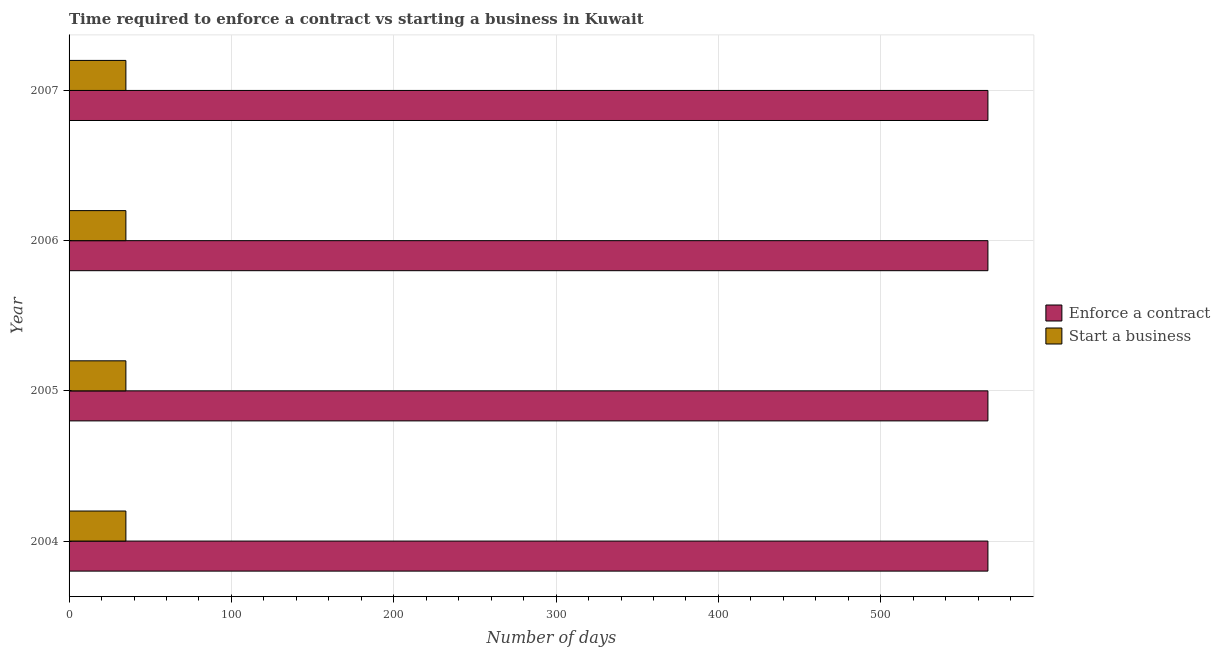How many different coloured bars are there?
Offer a very short reply. 2. How many groups of bars are there?
Provide a succinct answer. 4. Are the number of bars per tick equal to the number of legend labels?
Ensure brevity in your answer.  Yes. Are the number of bars on each tick of the Y-axis equal?
Make the answer very short. Yes. What is the label of the 1st group of bars from the top?
Make the answer very short. 2007. What is the number of days to start a business in 2007?
Offer a very short reply. 35. Across all years, what is the maximum number of days to enforece a contract?
Your answer should be compact. 566. Across all years, what is the minimum number of days to start a business?
Give a very brief answer. 35. In which year was the number of days to enforece a contract maximum?
Ensure brevity in your answer.  2004. What is the total number of days to enforece a contract in the graph?
Offer a very short reply. 2264. What is the difference between the number of days to start a business in 2005 and that in 2006?
Keep it short and to the point. 0. What is the difference between the number of days to enforece a contract in 2006 and the number of days to start a business in 2004?
Make the answer very short. 531. What is the average number of days to start a business per year?
Your answer should be very brief. 35. In the year 2006, what is the difference between the number of days to start a business and number of days to enforece a contract?
Give a very brief answer. -531. In how many years, is the number of days to start a business greater than 100 days?
Provide a succinct answer. 0. What is the ratio of the number of days to start a business in 2004 to that in 2005?
Your response must be concise. 1. Is the number of days to start a business in 2004 less than that in 2005?
Offer a terse response. No. Is the difference between the number of days to start a business in 2006 and 2007 greater than the difference between the number of days to enforece a contract in 2006 and 2007?
Provide a short and direct response. No. In how many years, is the number of days to enforece a contract greater than the average number of days to enforece a contract taken over all years?
Give a very brief answer. 0. Is the sum of the number of days to enforece a contract in 2005 and 2007 greater than the maximum number of days to start a business across all years?
Provide a succinct answer. Yes. What does the 1st bar from the top in 2005 represents?
Make the answer very short. Start a business. What does the 1st bar from the bottom in 2006 represents?
Offer a very short reply. Enforce a contract. How many bars are there?
Make the answer very short. 8. Are the values on the major ticks of X-axis written in scientific E-notation?
Your answer should be compact. No. Does the graph contain any zero values?
Keep it short and to the point. No. How many legend labels are there?
Your response must be concise. 2. What is the title of the graph?
Make the answer very short. Time required to enforce a contract vs starting a business in Kuwait. Does "RDB concessional" appear as one of the legend labels in the graph?
Your answer should be very brief. No. What is the label or title of the X-axis?
Provide a short and direct response. Number of days. What is the label or title of the Y-axis?
Keep it short and to the point. Year. What is the Number of days in Enforce a contract in 2004?
Make the answer very short. 566. What is the Number of days of Start a business in 2004?
Offer a terse response. 35. What is the Number of days of Enforce a contract in 2005?
Provide a succinct answer. 566. What is the Number of days in Start a business in 2005?
Ensure brevity in your answer.  35. What is the Number of days in Enforce a contract in 2006?
Offer a terse response. 566. What is the Number of days of Start a business in 2006?
Provide a succinct answer. 35. What is the Number of days in Enforce a contract in 2007?
Your answer should be compact. 566. Across all years, what is the maximum Number of days of Enforce a contract?
Make the answer very short. 566. Across all years, what is the maximum Number of days in Start a business?
Offer a terse response. 35. Across all years, what is the minimum Number of days of Enforce a contract?
Your response must be concise. 566. Across all years, what is the minimum Number of days of Start a business?
Keep it short and to the point. 35. What is the total Number of days in Enforce a contract in the graph?
Offer a very short reply. 2264. What is the total Number of days of Start a business in the graph?
Provide a succinct answer. 140. What is the difference between the Number of days of Start a business in 2004 and that in 2005?
Your answer should be compact. 0. What is the difference between the Number of days in Start a business in 2004 and that in 2006?
Your answer should be compact. 0. What is the difference between the Number of days of Start a business in 2004 and that in 2007?
Provide a short and direct response. 0. What is the difference between the Number of days in Enforce a contract in 2005 and that in 2006?
Ensure brevity in your answer.  0. What is the difference between the Number of days of Enforce a contract in 2004 and the Number of days of Start a business in 2005?
Ensure brevity in your answer.  531. What is the difference between the Number of days in Enforce a contract in 2004 and the Number of days in Start a business in 2006?
Offer a very short reply. 531. What is the difference between the Number of days of Enforce a contract in 2004 and the Number of days of Start a business in 2007?
Your answer should be very brief. 531. What is the difference between the Number of days of Enforce a contract in 2005 and the Number of days of Start a business in 2006?
Provide a succinct answer. 531. What is the difference between the Number of days of Enforce a contract in 2005 and the Number of days of Start a business in 2007?
Your response must be concise. 531. What is the difference between the Number of days of Enforce a contract in 2006 and the Number of days of Start a business in 2007?
Your answer should be compact. 531. What is the average Number of days in Enforce a contract per year?
Your answer should be compact. 566. In the year 2004, what is the difference between the Number of days of Enforce a contract and Number of days of Start a business?
Keep it short and to the point. 531. In the year 2005, what is the difference between the Number of days of Enforce a contract and Number of days of Start a business?
Your answer should be compact. 531. In the year 2006, what is the difference between the Number of days in Enforce a contract and Number of days in Start a business?
Provide a short and direct response. 531. In the year 2007, what is the difference between the Number of days of Enforce a contract and Number of days of Start a business?
Keep it short and to the point. 531. What is the ratio of the Number of days in Start a business in 2004 to that in 2005?
Your answer should be very brief. 1. What is the ratio of the Number of days in Enforce a contract in 2004 to that in 2006?
Make the answer very short. 1. What is the ratio of the Number of days of Start a business in 2004 to that in 2006?
Give a very brief answer. 1. What is the ratio of the Number of days in Enforce a contract in 2004 to that in 2007?
Give a very brief answer. 1. What is the ratio of the Number of days of Start a business in 2004 to that in 2007?
Make the answer very short. 1. What is the ratio of the Number of days in Start a business in 2005 to that in 2006?
Make the answer very short. 1. What is the ratio of the Number of days of Enforce a contract in 2005 to that in 2007?
Your response must be concise. 1. What is the difference between the highest and the lowest Number of days in Enforce a contract?
Keep it short and to the point. 0. 